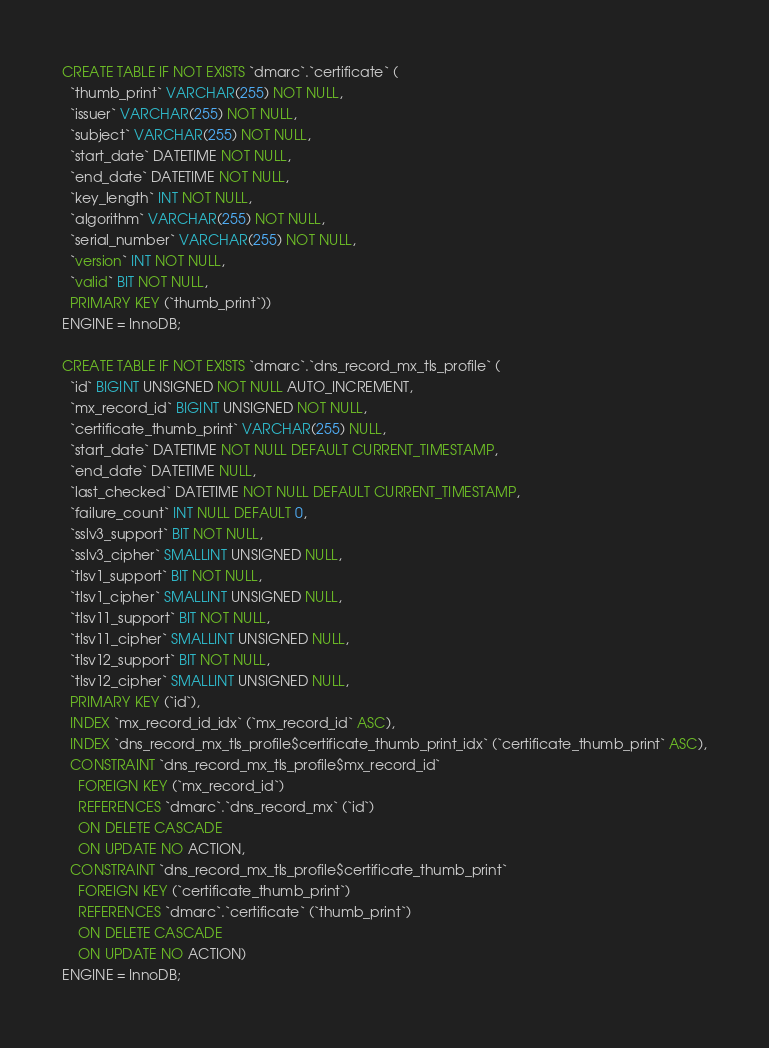<code> <loc_0><loc_0><loc_500><loc_500><_SQL_>CREATE TABLE IF NOT EXISTS `dmarc`.`certificate` (
  `thumb_print` VARCHAR(255) NOT NULL,
  `issuer` VARCHAR(255) NOT NULL,
  `subject` VARCHAR(255) NOT NULL,
  `start_date` DATETIME NOT NULL,
  `end_date` DATETIME NOT NULL,
  `key_length` INT NOT NULL,
  `algorithm` VARCHAR(255) NOT NULL,
  `serial_number` VARCHAR(255) NOT NULL,
  `version` INT NOT NULL,
  `valid` BIT NOT NULL,
  PRIMARY KEY (`thumb_print`))
ENGINE = InnoDB;

CREATE TABLE IF NOT EXISTS `dmarc`.`dns_record_mx_tls_profile` (
  `id` BIGINT UNSIGNED NOT NULL AUTO_INCREMENT,
  `mx_record_id` BIGINT UNSIGNED NOT NULL,
  `certificate_thumb_print` VARCHAR(255) NULL,
  `start_date` DATETIME NOT NULL DEFAULT CURRENT_TIMESTAMP,
  `end_date` DATETIME NULL,
  `last_checked` DATETIME NOT NULL DEFAULT CURRENT_TIMESTAMP,
  `failure_count` INT NULL DEFAULT 0,
  `sslv3_support` BIT NOT NULL,
  `sslv3_cipher` SMALLINT UNSIGNED NULL,
  `tlsv1_support` BIT NOT NULL,
  `tlsv1_cipher` SMALLINT UNSIGNED NULL,
  `tlsv11_support` BIT NOT NULL,
  `tlsv11_cipher` SMALLINT UNSIGNED NULL,
  `tlsv12_support` BIT NOT NULL,
  `tlsv12_cipher` SMALLINT UNSIGNED NULL,
  PRIMARY KEY (`id`),
  INDEX `mx_record_id_idx` (`mx_record_id` ASC),
  INDEX `dns_record_mx_tls_profile$certificate_thumb_print_idx` (`certificate_thumb_print` ASC),
  CONSTRAINT `dns_record_mx_tls_profile$mx_record_id`
    FOREIGN KEY (`mx_record_id`)
    REFERENCES `dmarc`.`dns_record_mx` (`id`)
    ON DELETE CASCADE
    ON UPDATE NO ACTION,
  CONSTRAINT `dns_record_mx_tls_profile$certificate_thumb_print`
    FOREIGN KEY (`certificate_thumb_print`)
    REFERENCES `dmarc`.`certificate` (`thumb_print`)
    ON DELETE CASCADE
    ON UPDATE NO ACTION)
ENGINE = InnoDB;</code> 